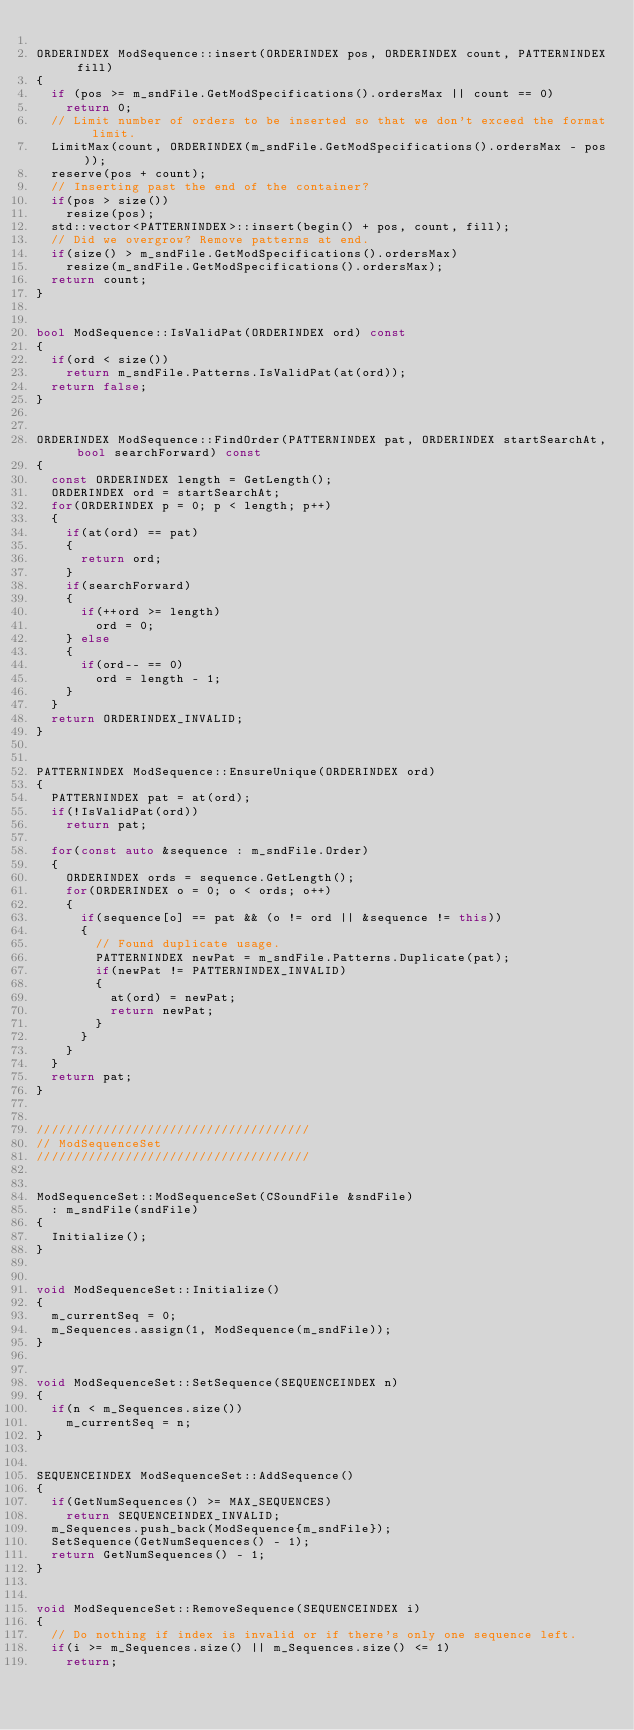<code> <loc_0><loc_0><loc_500><loc_500><_C++_>
ORDERINDEX ModSequence::insert(ORDERINDEX pos, ORDERINDEX count, PATTERNINDEX fill)
{
	if (pos >= m_sndFile.GetModSpecifications().ordersMax || count == 0)
		return 0;
	// Limit number of orders to be inserted so that we don't exceed the format limit.
	LimitMax(count, ORDERINDEX(m_sndFile.GetModSpecifications().ordersMax - pos));
	reserve(pos + count);
	// Inserting past the end of the container?
	if(pos > size())
		resize(pos);
	std::vector<PATTERNINDEX>::insert(begin() + pos, count, fill);
	// Did we overgrow? Remove patterns at end.
	if(size() > m_sndFile.GetModSpecifications().ordersMax)
		resize(m_sndFile.GetModSpecifications().ordersMax);
	return count;
}


bool ModSequence::IsValidPat(ORDERINDEX ord) const
{
	if(ord < size())
		return m_sndFile.Patterns.IsValidPat(at(ord));
	return false;
}


ORDERINDEX ModSequence::FindOrder(PATTERNINDEX pat, ORDERINDEX startSearchAt, bool searchForward) const
{
	const ORDERINDEX length = GetLength();
	ORDERINDEX ord = startSearchAt;
	for(ORDERINDEX p = 0; p < length; p++)
	{
		if(at(ord) == pat)
		{
			return ord;
		}
		if(searchForward)
		{
			if(++ord >= length)
				ord = 0;
		} else
		{
			if(ord-- == 0)
				ord = length - 1;
		}
	}
	return ORDERINDEX_INVALID;
}


PATTERNINDEX ModSequence::EnsureUnique(ORDERINDEX ord)
{
	PATTERNINDEX pat = at(ord);
	if(!IsValidPat(ord))
		return pat;

	for(const auto &sequence : m_sndFile.Order)
	{
		ORDERINDEX ords = sequence.GetLength();
		for(ORDERINDEX o = 0; o < ords; o++)
		{
			if(sequence[o] == pat && (o != ord || &sequence != this))
			{
				// Found duplicate usage.
				PATTERNINDEX newPat = m_sndFile.Patterns.Duplicate(pat);
				if(newPat != PATTERNINDEX_INVALID)
				{
					at(ord) = newPat;
					return newPat;
				}
			}
		}
	}
	return pat;
}


/////////////////////////////////////
// ModSequenceSet
/////////////////////////////////////


ModSequenceSet::ModSequenceSet(CSoundFile &sndFile)
	: m_sndFile(sndFile)
{
	Initialize();
}


void ModSequenceSet::Initialize()
{
	m_currentSeq = 0;
	m_Sequences.assign(1, ModSequence(m_sndFile));
}


void ModSequenceSet::SetSequence(SEQUENCEINDEX n)
{
	if(n < m_Sequences.size())
		m_currentSeq = n;
}


SEQUENCEINDEX ModSequenceSet::AddSequence()
{
	if(GetNumSequences() >= MAX_SEQUENCES)
		return SEQUENCEINDEX_INVALID;
	m_Sequences.push_back(ModSequence{m_sndFile});
	SetSequence(GetNumSequences() - 1);
	return GetNumSequences() - 1;
}


void ModSequenceSet::RemoveSequence(SEQUENCEINDEX i)
{
	// Do nothing if index is invalid or if there's only one sequence left.
	if(i >= m_Sequences.size() || m_Sequences.size() <= 1)
		return;</code> 